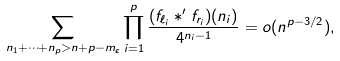<formula> <loc_0><loc_0><loc_500><loc_500>\sum _ { n _ { 1 } + \cdots + n _ { p } > n + p - m _ { \varepsilon } } \prod _ { i = 1 } ^ { p } \frac { ( f _ { \ell _ { i } } * ^ { \prime } f _ { r _ { i } } ) ( n _ { i } ) } { 4 ^ { n _ { i } - 1 } } = o ( n ^ { p - 3 / 2 } ) ,</formula> 